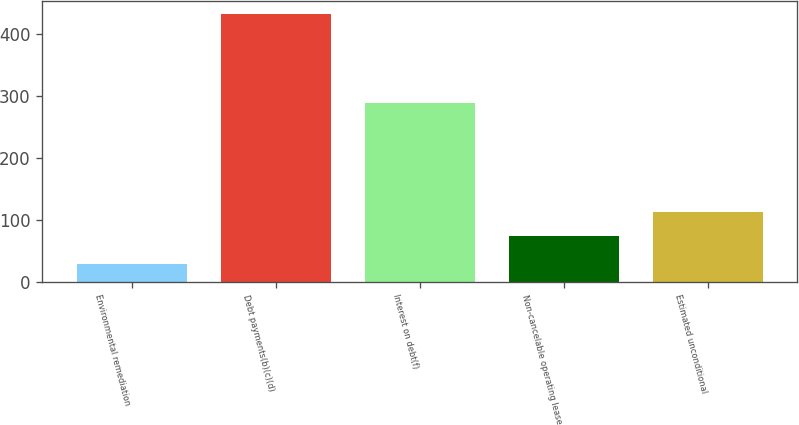Convert chart. <chart><loc_0><loc_0><loc_500><loc_500><bar_chart><fcel>Environmental remediation<fcel>Debt payments(b)(c)(d)<fcel>Interest on debt(f)<fcel>Non-cancelable operating lease<fcel>Estimated unconditional<nl><fcel>29<fcel>432<fcel>289<fcel>73<fcel>113.3<nl></chart> 